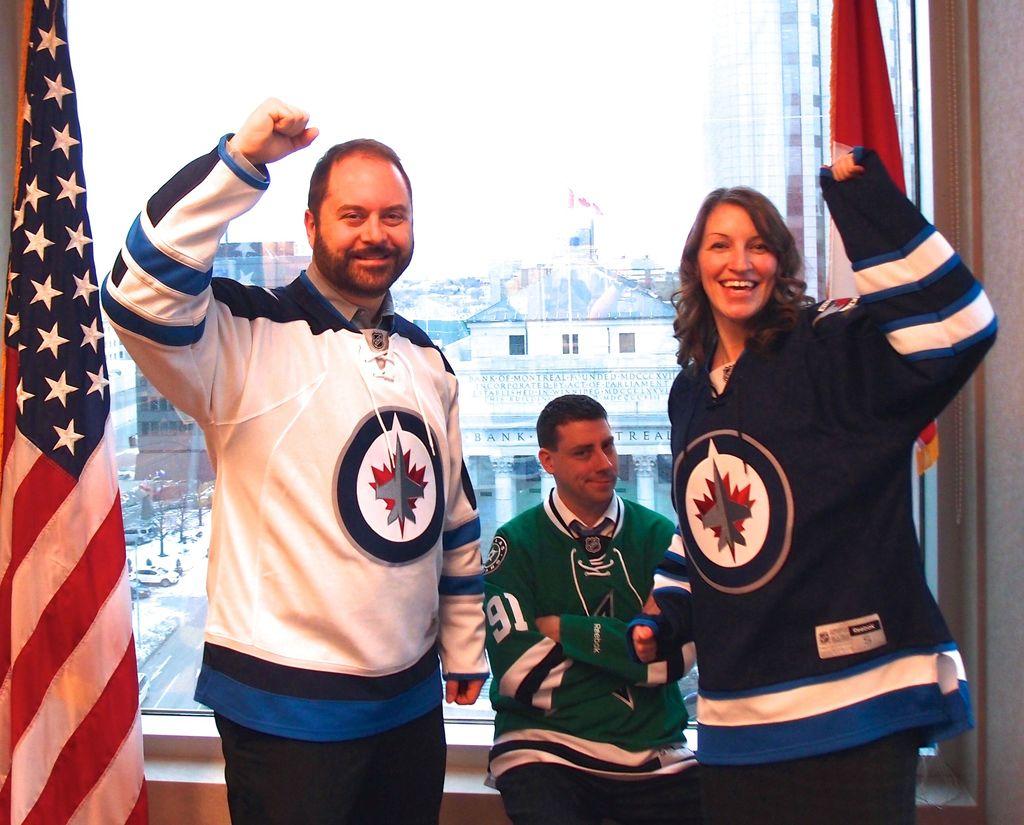What number is the guy in green wearing?
Offer a terse response. 91. 